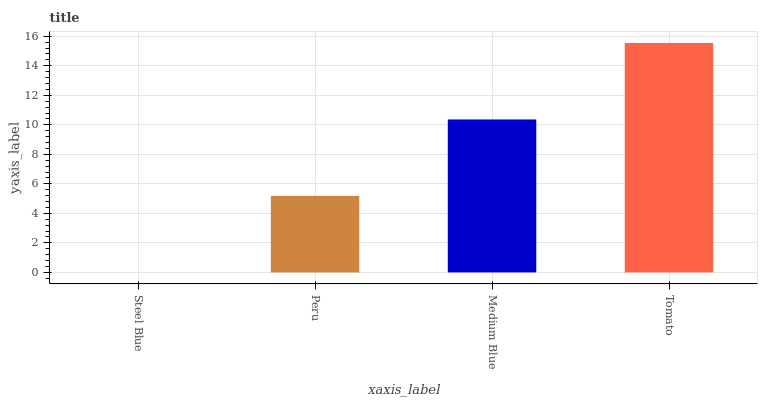Is Steel Blue the minimum?
Answer yes or no. Yes. Is Tomato the maximum?
Answer yes or no. Yes. Is Peru the minimum?
Answer yes or no. No. Is Peru the maximum?
Answer yes or no. No. Is Peru greater than Steel Blue?
Answer yes or no. Yes. Is Steel Blue less than Peru?
Answer yes or no. Yes. Is Steel Blue greater than Peru?
Answer yes or no. No. Is Peru less than Steel Blue?
Answer yes or no. No. Is Medium Blue the high median?
Answer yes or no. Yes. Is Peru the low median?
Answer yes or no. Yes. Is Peru the high median?
Answer yes or no. No. Is Tomato the low median?
Answer yes or no. No. 